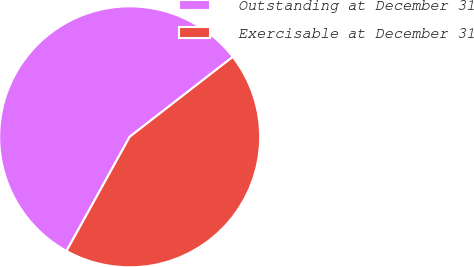Convert chart to OTSL. <chart><loc_0><loc_0><loc_500><loc_500><pie_chart><fcel>Outstanding at December 31<fcel>Exercisable at December 31<nl><fcel>56.46%<fcel>43.54%<nl></chart> 